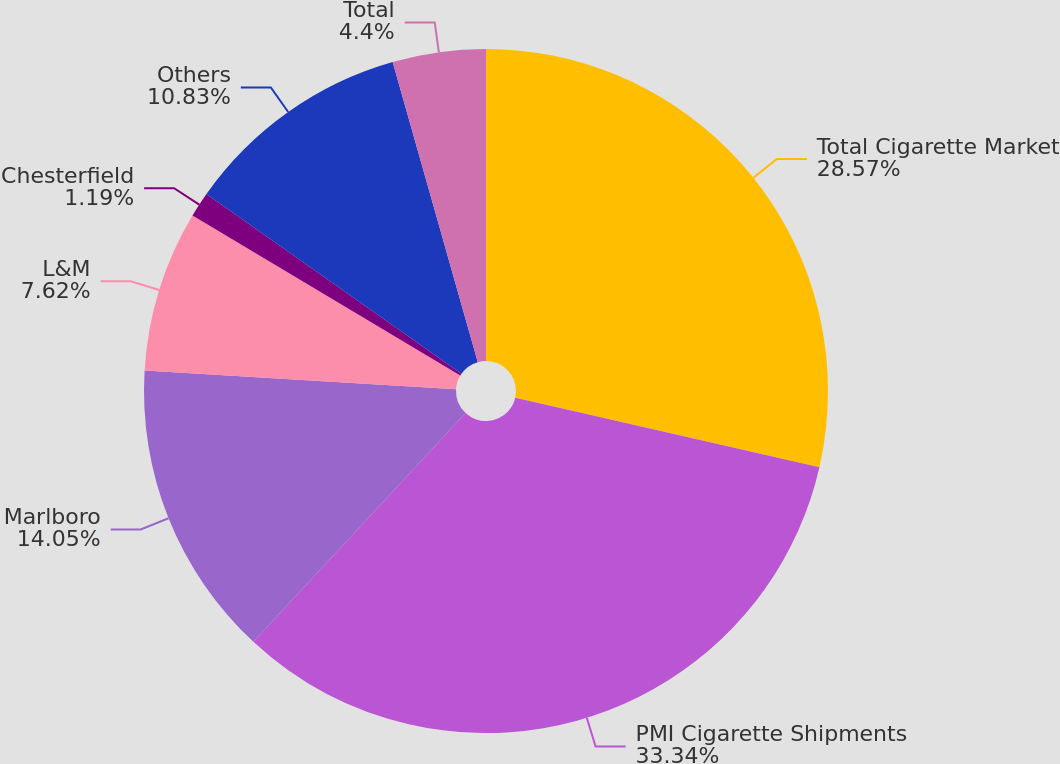Convert chart. <chart><loc_0><loc_0><loc_500><loc_500><pie_chart><fcel>Total Cigarette Market<fcel>PMI Cigarette Shipments<fcel>Marlboro<fcel>L&M<fcel>Chesterfield<fcel>Others<fcel>Total<nl><fcel>28.57%<fcel>33.33%<fcel>14.05%<fcel>7.62%<fcel>1.19%<fcel>10.83%<fcel>4.4%<nl></chart> 